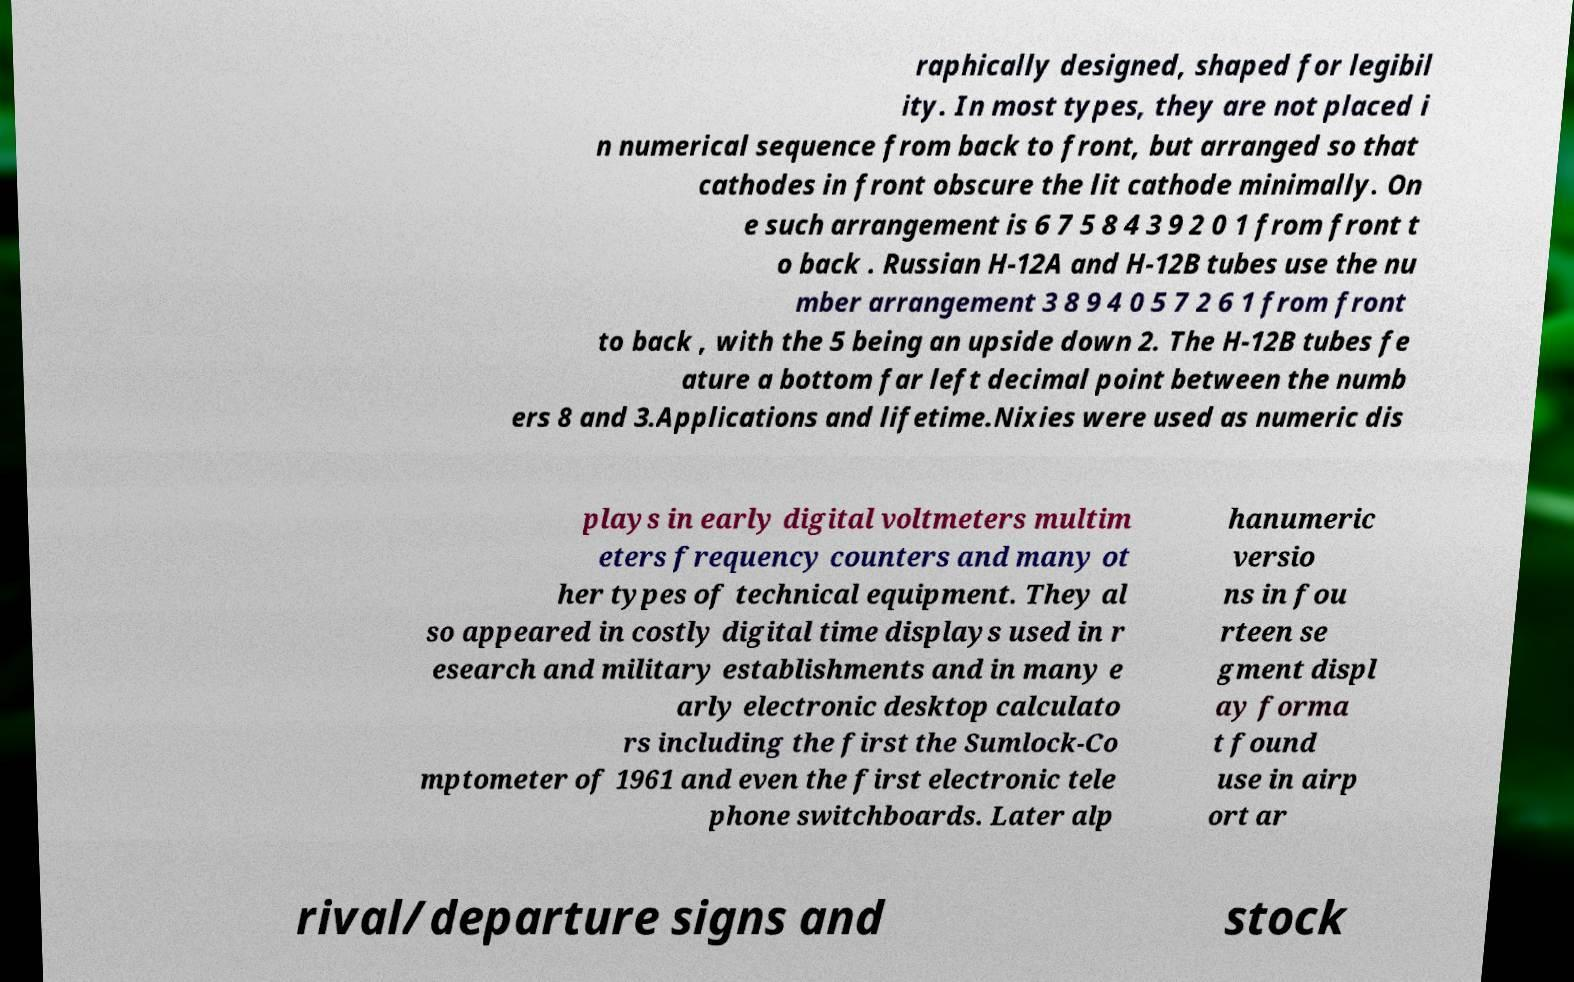Please read and relay the text visible in this image. What does it say? raphically designed, shaped for legibil ity. In most types, they are not placed i n numerical sequence from back to front, but arranged so that cathodes in front obscure the lit cathode minimally. On e such arrangement is 6 7 5 8 4 3 9 2 0 1 from front t o back . Russian H-12A and H-12B tubes use the nu mber arrangement 3 8 9 4 0 5 7 2 6 1 from front to back , with the 5 being an upside down 2. The H-12B tubes fe ature a bottom far left decimal point between the numb ers 8 and 3.Applications and lifetime.Nixies were used as numeric dis plays in early digital voltmeters multim eters frequency counters and many ot her types of technical equipment. They al so appeared in costly digital time displays used in r esearch and military establishments and in many e arly electronic desktop calculato rs including the first the Sumlock-Co mptometer of 1961 and even the first electronic tele phone switchboards. Later alp hanumeric versio ns in fou rteen se gment displ ay forma t found use in airp ort ar rival/departure signs and stock 